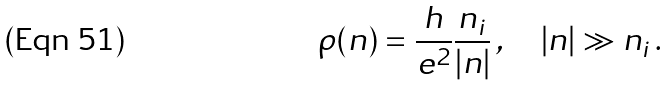<formula> <loc_0><loc_0><loc_500><loc_500>\rho ( n ) = \frac { h } { e ^ { 2 } } \frac { n _ { i } } { | n | } \, , \quad | n | \gg n _ { i } \, .</formula> 